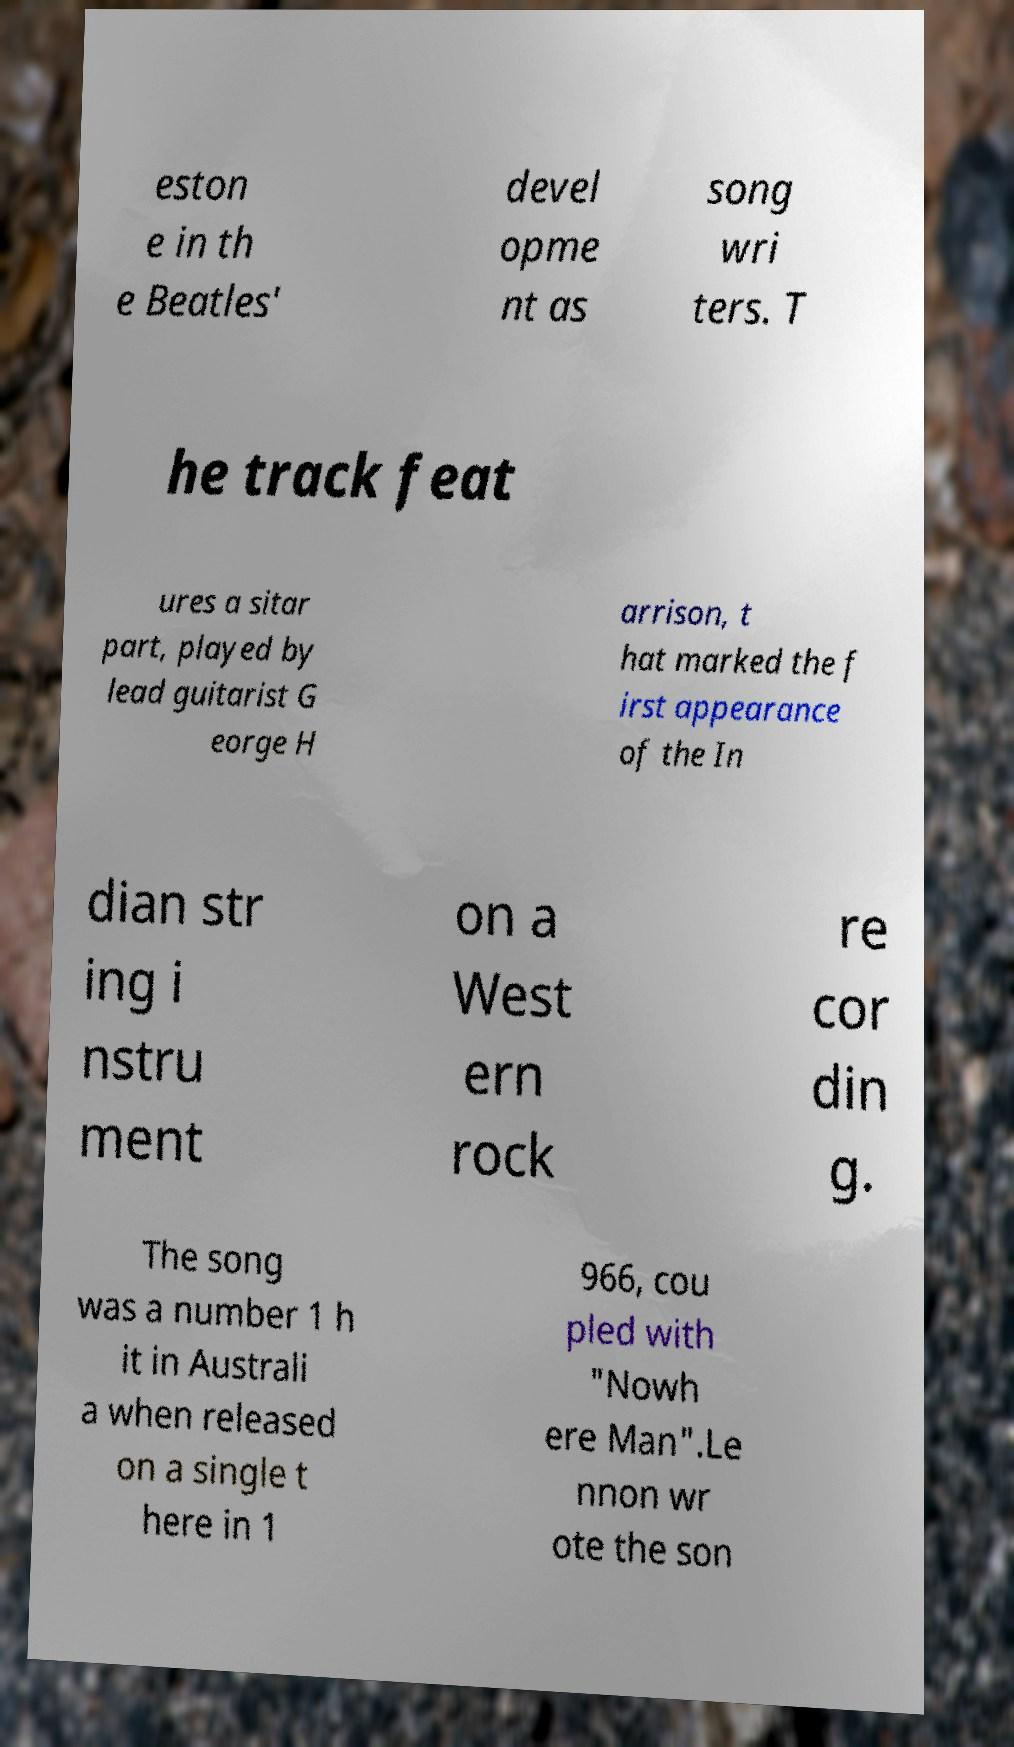Could you extract and type out the text from this image? eston e in th e Beatles' devel opme nt as song wri ters. T he track feat ures a sitar part, played by lead guitarist G eorge H arrison, t hat marked the f irst appearance of the In dian str ing i nstru ment on a West ern rock re cor din g. The song was a number 1 h it in Australi a when released on a single t here in 1 966, cou pled with "Nowh ere Man".Le nnon wr ote the son 